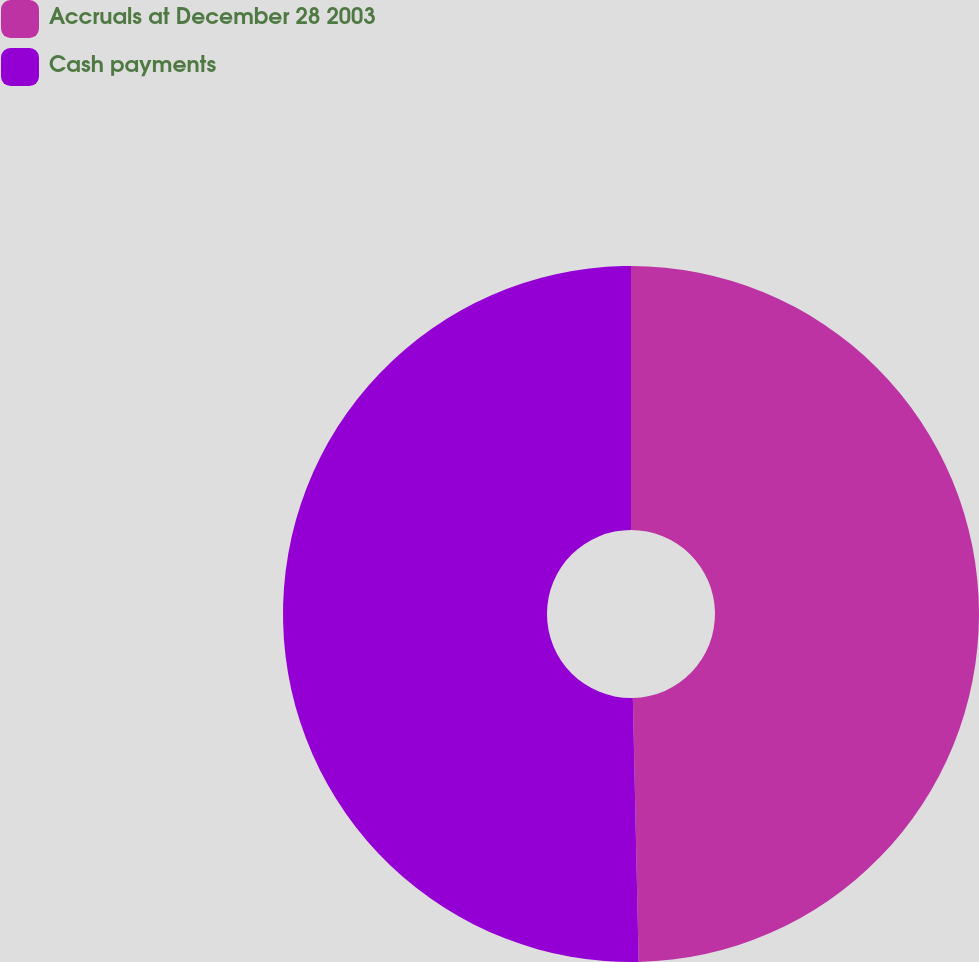<chart> <loc_0><loc_0><loc_500><loc_500><pie_chart><fcel>Accruals at December 28 2003<fcel>Cash payments<nl><fcel>49.65%<fcel>50.35%<nl></chart> 